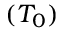<formula> <loc_0><loc_0><loc_500><loc_500>( T _ { 0 } )</formula> 